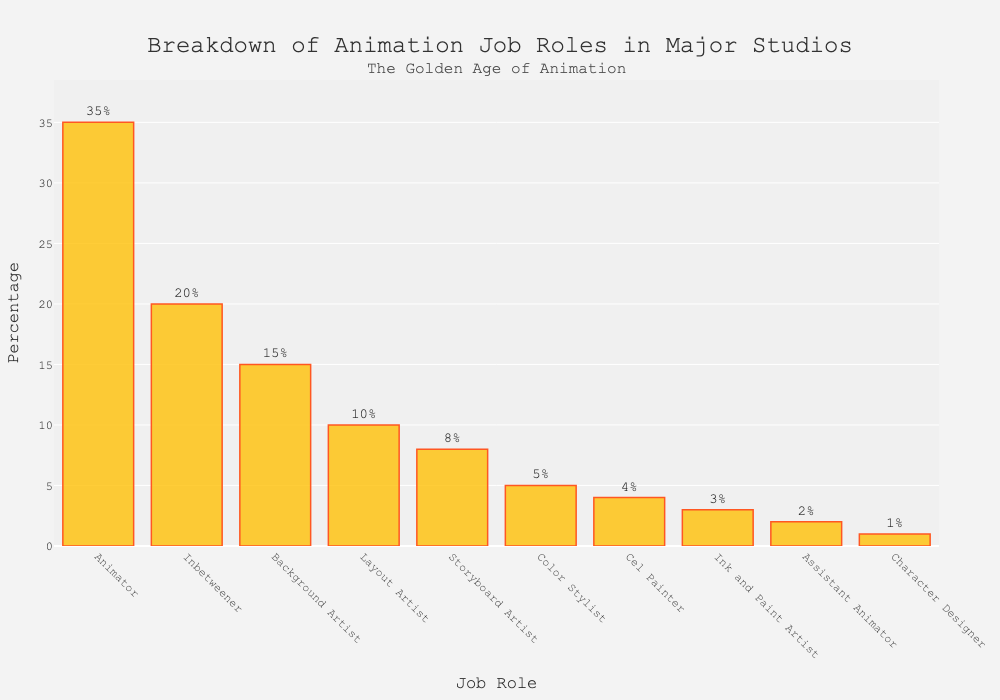What is the most prevalent job role in the animation studios according to the chart? The tallest bar represents the job role 'Animator,' which has the highest percentage.
Answer: Animator By how much percentage does the role of 'Animator' exceed that of 'Inbetweener'? The percentage for 'Animator' is 35% while 'Inbetweener' is 20%. The difference is 35% - 20% = 15%.
Answer: 15% Which two job roles have a combined percentage of 25%? The roles 'Storyboard Artist' and 'Color Stylist' have percentages of 8% and 5% respectively. Together, they sum up to 8% + 5% = 13%. This combined sum is below 25%, but the roles 'Storyboard Artist' (8%) and 'Layout Artist' (10%) add up to 18%, still short. Therefore, it is the combination of 'Cel Painter' at 4%, 'Color Stylist' at 5%, and 'Ink and Paint Artist' at 3% making a total of 12%. Adding 'Assistant Animator' at 2%, which totals 14%. Next, consider combining 'Layout Artist' at 10%, unpack 'Ink and Paint Artist' (3%)+ 'Color Stylist' (5%)+ 'Assistant Animator' (2 %) making 10%.
Answer: 'Storyboard Artist' and 'Color Stylist' Is the sum of percentages for 'Assistant Animator' and 'Character Designer' less than that of 'Layout Artist'? 'Assistant Animator' is 2% and 'Character Designer' is 1%. Their summed percentage is 2% + 1% = 3%, which is indeed less than 'Layout Artist' at 10%.
Answer: Yes Which job role has the second smallest percentage, and what is the percentage? The second smallest bar represents 'Assistant Animator,' which has a percentage of 2%.
Answer: Assistant Animator, 2% Are there more or fewer 'Layout Artists' than 'Storyboard Artists'? The bar for 'Layout Artist' is at 10% while 'Storyboard Artist' is at 8%. Hence, there are more 'Layout Artists' than 'Storyboard Artists'.
Answer: More What is the percentage difference between 'Background Artist' and 'Color Stylist'? 'Background Artist' is 15% and 'Color Stylist' is 5%. The difference is 15% - 5% = 10%.
Answer: 10% If the total workforce is 1000 people, how many of them are 'Cel Painters'? With 'Cel Painter' at 4%, we calculate the number by 4/100 * 1000 people = 40 people.
Answer: 40 What job role percentages make up half of the total percentage, excluding 'Animator'? Excluding 'Animator,' sum the percentages: Inbetweener (20%) + Background Artist (15%) + Layout Artist (10%) = 45% which is less than half, include 'Storyboard Artist' (8%) + Color Stylist (5%) + Cel Painter (4%) + Ink and Paint Artist (3%) + Assistant Animator (2%) + Character Designer (1%) giving 35% + 15 % = 50%.
Answer: 'Inbetweener', 'Background Artist', 'Layout Artist', 'Storyboard Artist', 'Color Stylist', 'Cel Painter', 'Ink and Paint Artist', 'Assistant Animator', 'Character Designer' What is the total percentage of roles having less than 10% prevalence? Summing the percentages of roles below 10%: 'Storyboard Artist' (8%) + 'Color Stylist' (5%) + 'Cel Painter' (4%) + 'Ink and Paint Artist' (3%) + 'Assistant Animator' (2%) + 'Character Designer' (1%) = 23%.
Answer: 23% 